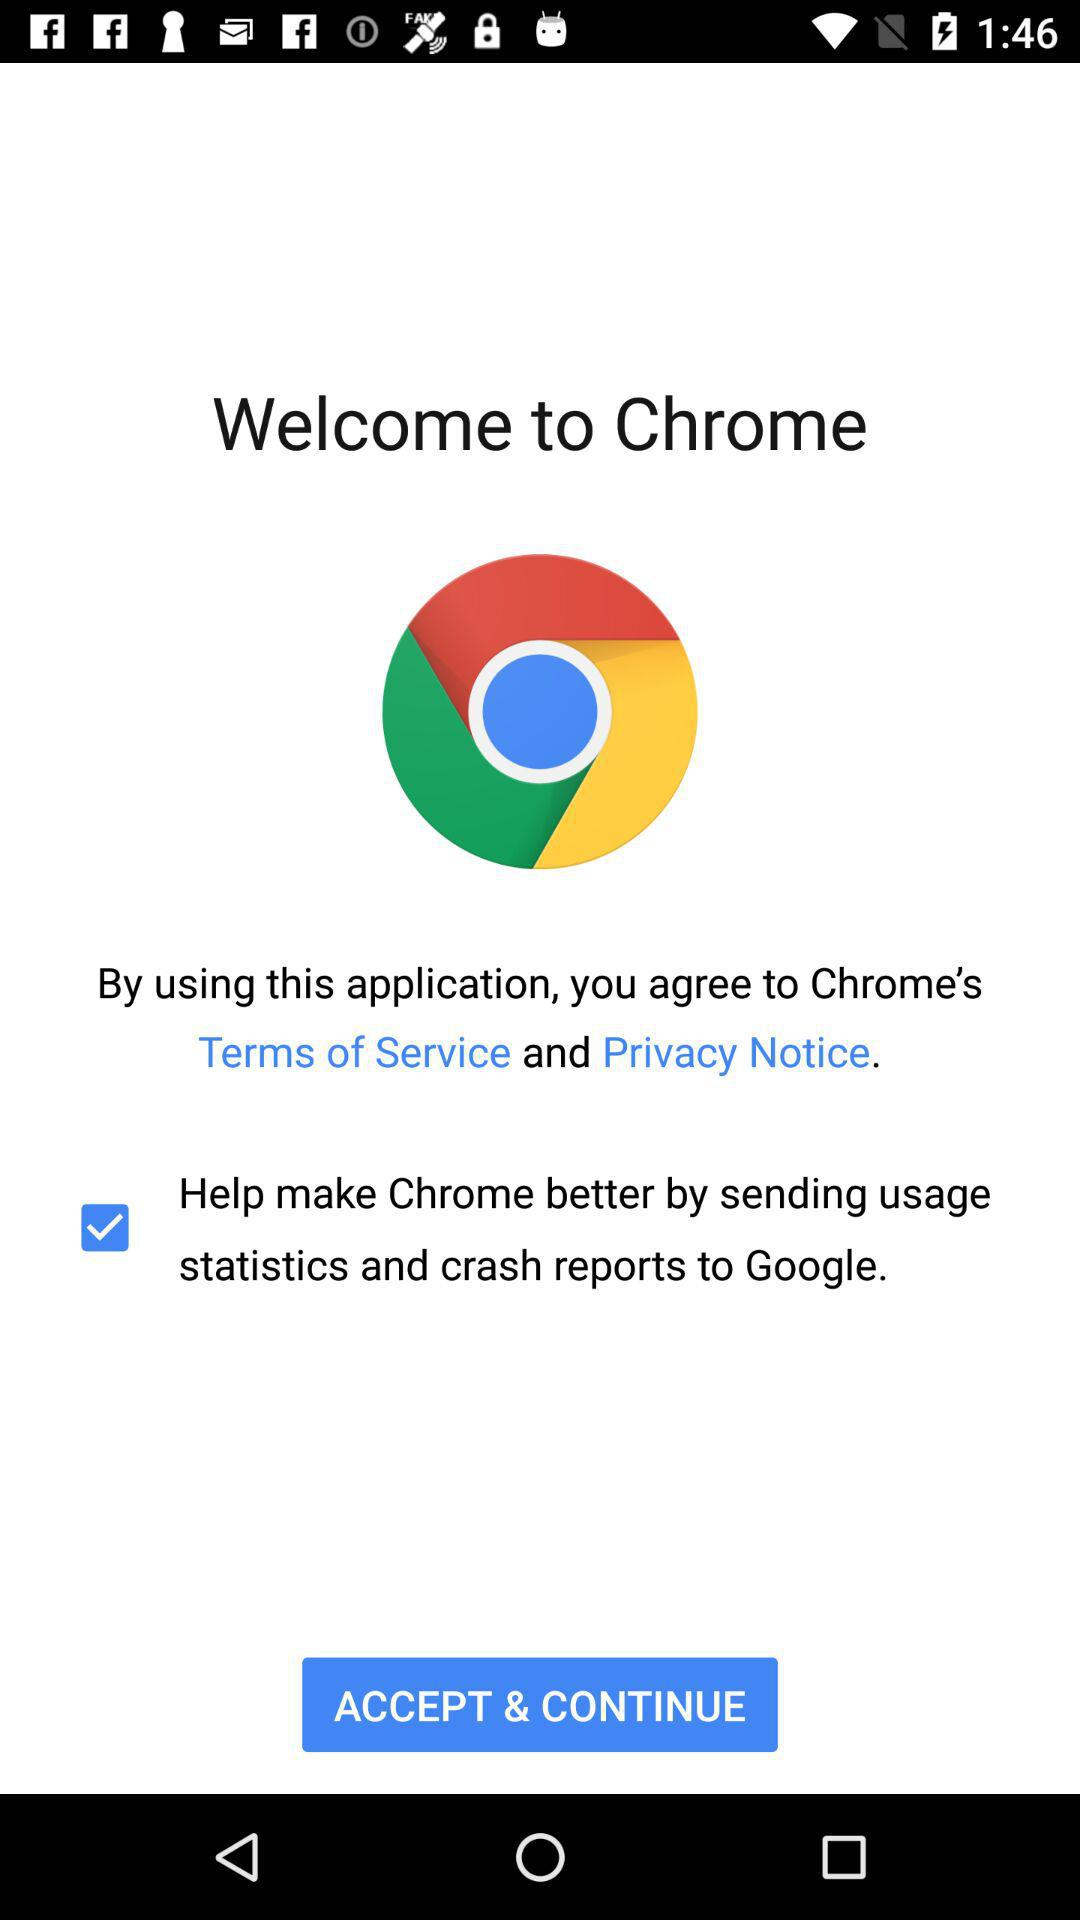What is the application name? The application name is "Chrome". 